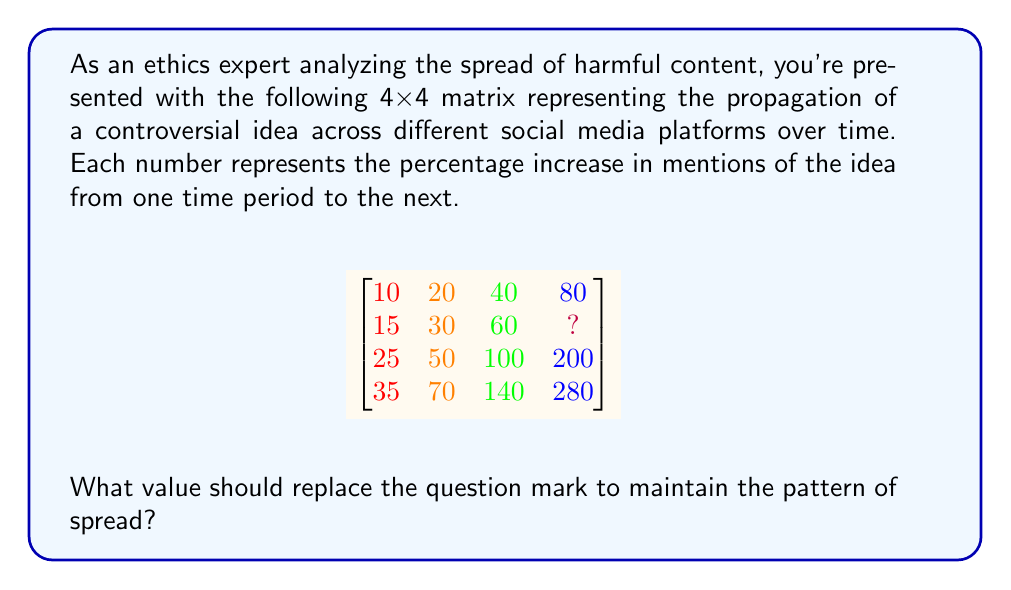Teach me how to tackle this problem. To solve this problem, we need to analyze the pattern within each row and between rows:

1. Observe the pattern within each row:
   - In each row, each number doubles from left to right.
   - For example, in the first row: 10 → 20 → 40 → 80

2. Observe the pattern between rows:
   - The starting number (leftmost column) increases by 5 for each row from top to bottom.
   - Row 1 starts with 10, Row 2 with 15, Row 3 with 25, and Row 4 with 35.

3. Focus on the second row where the question mark is located:
   - The pattern starts with 15
   - It doubles to 30, then to 60

4. To maintain the pattern, the next number in the second row should be double 60:
   $60 * 2 = 120$

Therefore, the value that should replace the question mark is 120, maintaining both the doubling pattern within the row and the overall pattern of the matrix.
Answer: 120 